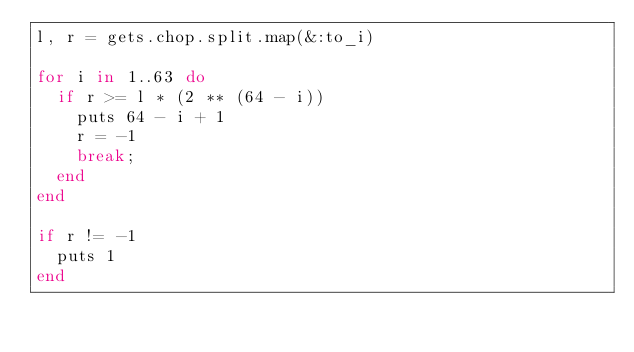Convert code to text. <code><loc_0><loc_0><loc_500><loc_500><_Ruby_>l, r = gets.chop.split.map(&:to_i)
 
for i in 1..63 do
  if r >= l * (2 ** (64 - i))
    puts 64 - i + 1
    r = -1
    break;
  end
end
 
if r != -1
  puts 1
end</code> 